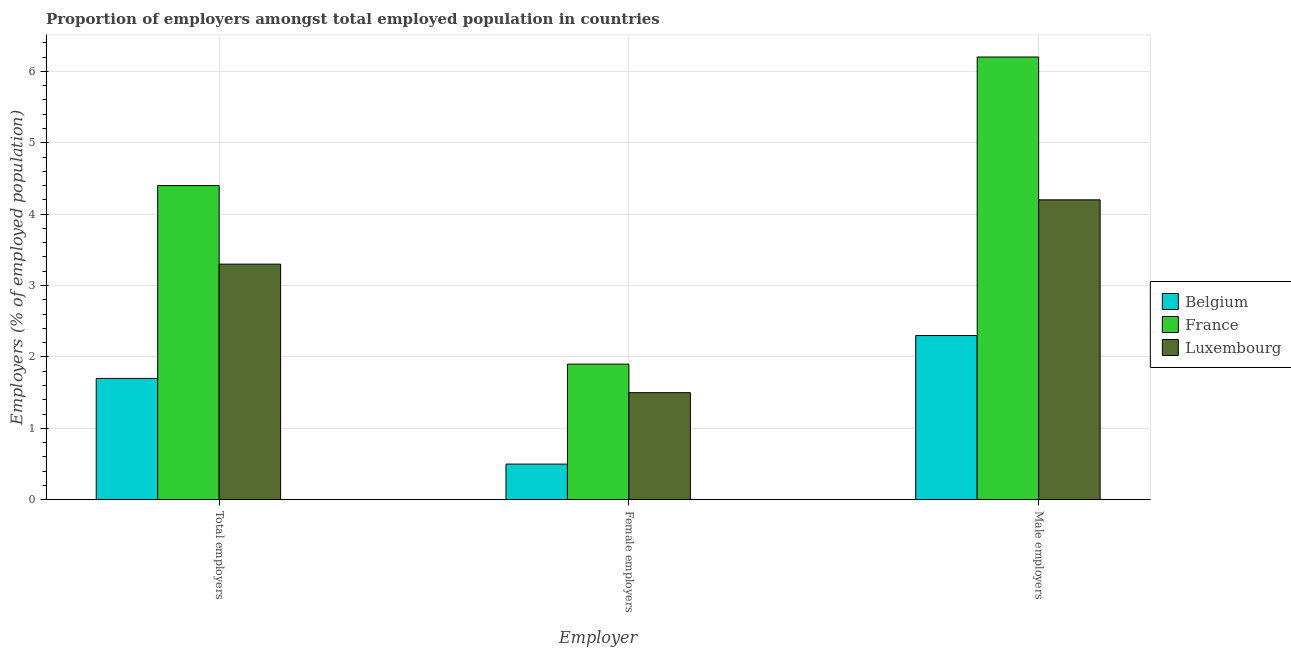How many groups of bars are there?
Offer a very short reply. 3. Are the number of bars on each tick of the X-axis equal?
Your answer should be compact. Yes. How many bars are there on the 2nd tick from the right?
Give a very brief answer. 3. What is the label of the 2nd group of bars from the left?
Your answer should be very brief. Female employers. What is the percentage of female employers in Luxembourg?
Provide a succinct answer. 1.5. Across all countries, what is the maximum percentage of male employers?
Offer a very short reply. 6.2. Across all countries, what is the minimum percentage of total employers?
Your answer should be very brief. 1.7. In which country was the percentage of male employers minimum?
Offer a terse response. Belgium. What is the total percentage of total employers in the graph?
Offer a terse response. 9.4. What is the difference between the percentage of total employers in France and that in Belgium?
Your answer should be very brief. 2.7. What is the difference between the percentage of male employers in Belgium and the percentage of total employers in France?
Give a very brief answer. -2.1. What is the average percentage of male employers per country?
Give a very brief answer. 4.23. What is the difference between the percentage of female employers and percentage of total employers in France?
Provide a succinct answer. -2.5. In how many countries, is the percentage of male employers greater than 0.6000000000000001 %?
Give a very brief answer. 3. What is the ratio of the percentage of total employers in Belgium to that in France?
Make the answer very short. 0.39. What is the difference between the highest and the second highest percentage of male employers?
Ensure brevity in your answer.  2. What is the difference between the highest and the lowest percentage of female employers?
Provide a succinct answer. 1.4. Is the sum of the percentage of female employers in Luxembourg and Belgium greater than the maximum percentage of total employers across all countries?
Keep it short and to the point. No. What does the 3rd bar from the right in Female employers represents?
Offer a terse response. Belgium. Are all the bars in the graph horizontal?
Give a very brief answer. No. How many countries are there in the graph?
Make the answer very short. 3. Are the values on the major ticks of Y-axis written in scientific E-notation?
Your response must be concise. No. Does the graph contain any zero values?
Give a very brief answer. No. Does the graph contain grids?
Your answer should be very brief. Yes. How many legend labels are there?
Provide a short and direct response. 3. What is the title of the graph?
Your response must be concise. Proportion of employers amongst total employed population in countries. What is the label or title of the X-axis?
Offer a very short reply. Employer. What is the label or title of the Y-axis?
Your response must be concise. Employers (% of employed population). What is the Employers (% of employed population) of Belgium in Total employers?
Your answer should be very brief. 1.7. What is the Employers (% of employed population) in France in Total employers?
Your response must be concise. 4.4. What is the Employers (% of employed population) in Luxembourg in Total employers?
Ensure brevity in your answer.  3.3. What is the Employers (% of employed population) in France in Female employers?
Your response must be concise. 1.9. What is the Employers (% of employed population) of Luxembourg in Female employers?
Ensure brevity in your answer.  1.5. What is the Employers (% of employed population) of Belgium in Male employers?
Offer a terse response. 2.3. What is the Employers (% of employed population) in France in Male employers?
Offer a terse response. 6.2. What is the Employers (% of employed population) in Luxembourg in Male employers?
Your answer should be very brief. 4.2. Across all Employer, what is the maximum Employers (% of employed population) in Belgium?
Your answer should be compact. 2.3. Across all Employer, what is the maximum Employers (% of employed population) of France?
Keep it short and to the point. 6.2. Across all Employer, what is the maximum Employers (% of employed population) of Luxembourg?
Your answer should be very brief. 4.2. Across all Employer, what is the minimum Employers (% of employed population) in France?
Offer a terse response. 1.9. What is the total Employers (% of employed population) of France in the graph?
Your answer should be compact. 12.5. What is the total Employers (% of employed population) in Luxembourg in the graph?
Offer a very short reply. 9. What is the difference between the Employers (% of employed population) in Belgium in Total employers and that in Female employers?
Provide a short and direct response. 1.2. What is the difference between the Employers (% of employed population) of France in Total employers and that in Male employers?
Keep it short and to the point. -1.8. What is the difference between the Employers (% of employed population) in Luxembourg in Total employers and that in Male employers?
Make the answer very short. -0.9. What is the difference between the Employers (% of employed population) in Belgium in Female employers and that in Male employers?
Keep it short and to the point. -1.8. What is the difference between the Employers (% of employed population) in France in Female employers and that in Male employers?
Ensure brevity in your answer.  -4.3. What is the difference between the Employers (% of employed population) of Luxembourg in Female employers and that in Male employers?
Provide a short and direct response. -2.7. What is the difference between the Employers (% of employed population) of Belgium in Total employers and the Employers (% of employed population) of France in Female employers?
Offer a terse response. -0.2. What is the difference between the Employers (% of employed population) of France in Total employers and the Employers (% of employed population) of Luxembourg in Female employers?
Give a very brief answer. 2.9. What is the difference between the Employers (% of employed population) in France in Female employers and the Employers (% of employed population) in Luxembourg in Male employers?
Offer a terse response. -2.3. What is the average Employers (% of employed population) of France per Employer?
Provide a short and direct response. 4.17. What is the difference between the Employers (% of employed population) in Belgium and Employers (% of employed population) in France in Total employers?
Provide a succinct answer. -2.7. What is the difference between the Employers (% of employed population) in Belgium and Employers (% of employed population) in Luxembourg in Total employers?
Provide a succinct answer. -1.6. What is the difference between the Employers (% of employed population) of France and Employers (% of employed population) of Luxembourg in Total employers?
Keep it short and to the point. 1.1. What is the difference between the Employers (% of employed population) of Belgium and Employers (% of employed population) of Luxembourg in Female employers?
Ensure brevity in your answer.  -1. What is the difference between the Employers (% of employed population) in France and Employers (% of employed population) in Luxembourg in Female employers?
Provide a succinct answer. 0.4. What is the difference between the Employers (% of employed population) of Belgium and Employers (% of employed population) of France in Male employers?
Your answer should be very brief. -3.9. What is the difference between the Employers (% of employed population) in Belgium and Employers (% of employed population) in Luxembourg in Male employers?
Your answer should be very brief. -1.9. What is the difference between the Employers (% of employed population) in France and Employers (% of employed population) in Luxembourg in Male employers?
Your answer should be compact. 2. What is the ratio of the Employers (% of employed population) in France in Total employers to that in Female employers?
Provide a succinct answer. 2.32. What is the ratio of the Employers (% of employed population) of Luxembourg in Total employers to that in Female employers?
Offer a very short reply. 2.2. What is the ratio of the Employers (% of employed population) in Belgium in Total employers to that in Male employers?
Your answer should be very brief. 0.74. What is the ratio of the Employers (% of employed population) of France in Total employers to that in Male employers?
Ensure brevity in your answer.  0.71. What is the ratio of the Employers (% of employed population) of Luxembourg in Total employers to that in Male employers?
Your answer should be very brief. 0.79. What is the ratio of the Employers (% of employed population) in Belgium in Female employers to that in Male employers?
Offer a very short reply. 0.22. What is the ratio of the Employers (% of employed population) in France in Female employers to that in Male employers?
Your response must be concise. 0.31. What is the ratio of the Employers (% of employed population) of Luxembourg in Female employers to that in Male employers?
Make the answer very short. 0.36. What is the difference between the highest and the second highest Employers (% of employed population) in Belgium?
Your answer should be compact. 0.6. What is the difference between the highest and the second highest Employers (% of employed population) of France?
Your answer should be compact. 1.8. What is the difference between the highest and the second highest Employers (% of employed population) in Luxembourg?
Offer a very short reply. 0.9. 